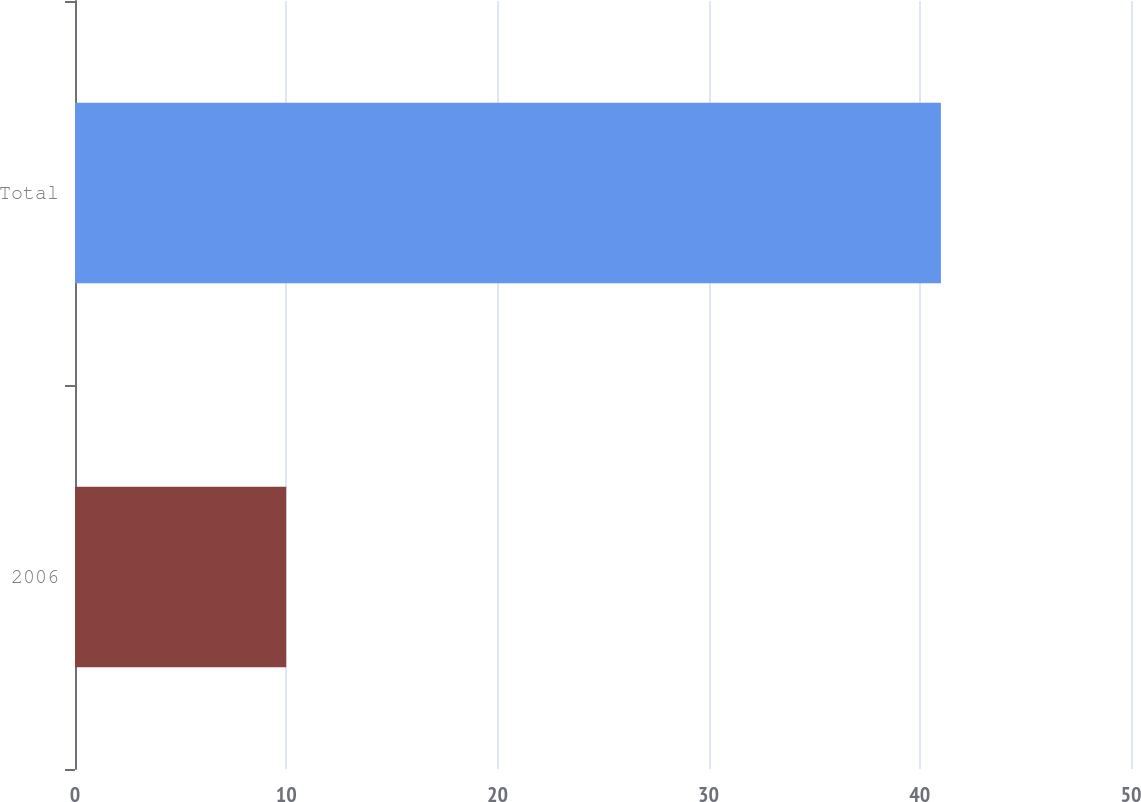<chart> <loc_0><loc_0><loc_500><loc_500><bar_chart><fcel>2006<fcel>Total<nl><fcel>10<fcel>41<nl></chart> 